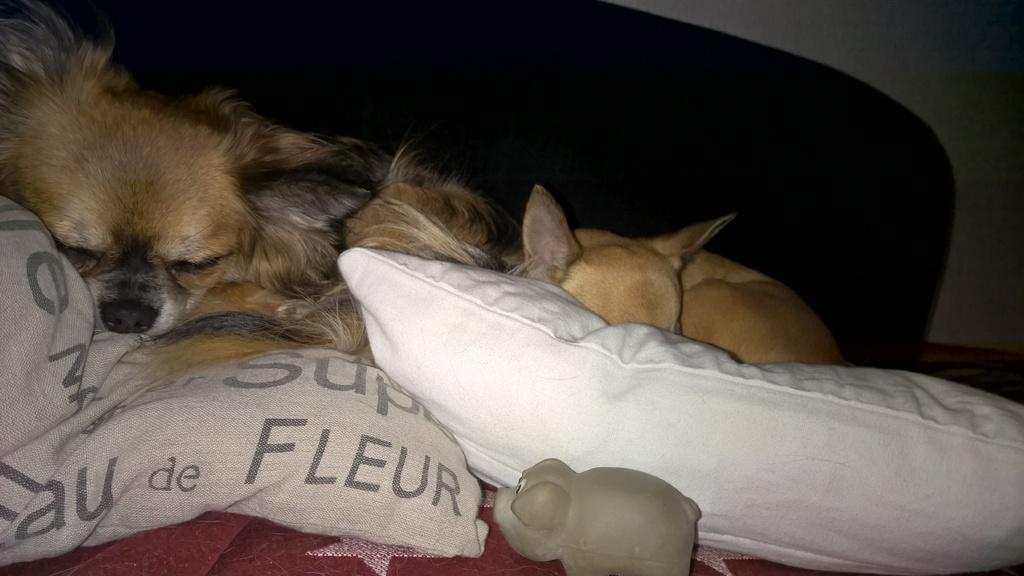How many dogs are present in the image? There are two dogs in the image. What are the dogs doing in the image? The dogs are sleeping on beds. What type of furniture is present in the image? There are pillows in the image. What can be seen in the background of the image? There is a wall and an unspecified object in the background of the image. What type of twig is the dog chewing on in the image? There is no twig present in the image; the dogs are sleeping on beds. Can you see a tin can in the image? There is no tin can visible in the image. 